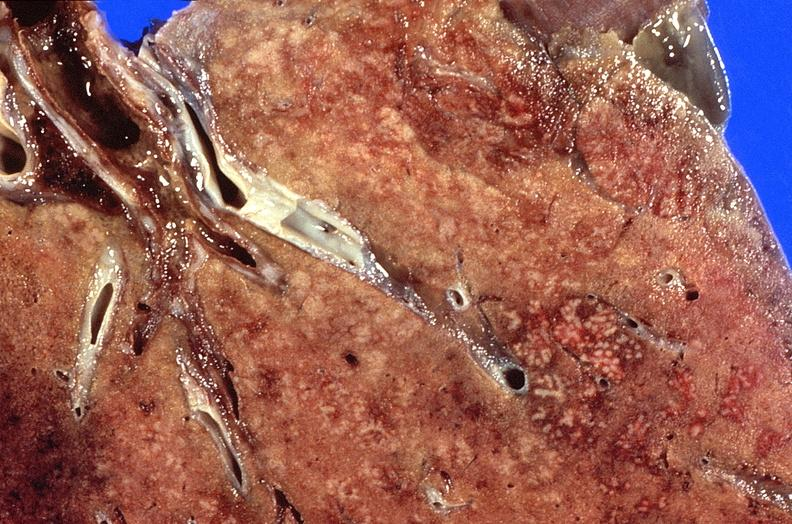what is present?
Answer the question using a single word or phrase. Respiratory 